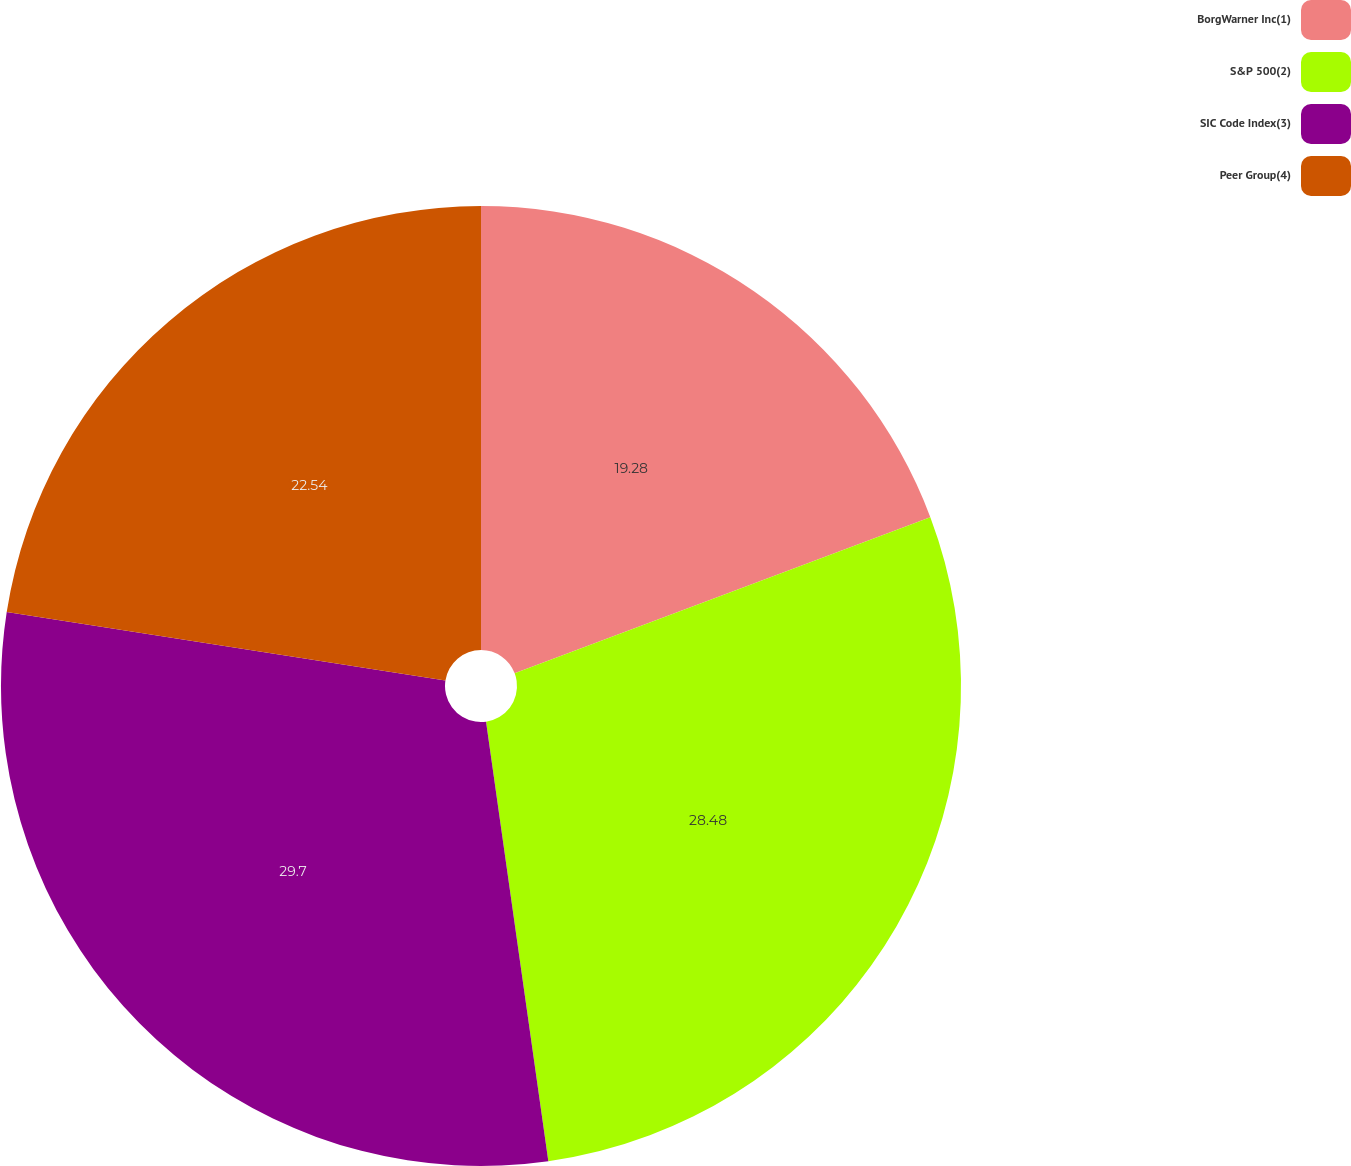Convert chart to OTSL. <chart><loc_0><loc_0><loc_500><loc_500><pie_chart><fcel>BorgWarner Inc(1)<fcel>S&P 500(2)<fcel>SIC Code Index(3)<fcel>Peer Group(4)<nl><fcel>19.28%<fcel>28.48%<fcel>29.7%<fcel>22.54%<nl></chart> 